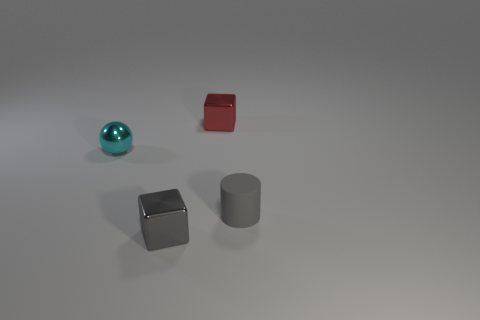There is a shiny thing in front of the small gray object that is on the right side of the small red object; what number of metallic balls are to the right of it?
Provide a short and direct response. 0. There is a metallic sphere; is its color the same as the tiny thing that is in front of the tiny cylinder?
Offer a terse response. No. What number of things are either objects that are behind the tiny cyan ball or tiny blocks that are behind the tiny rubber cylinder?
Give a very brief answer. 1. Are there more cylinders that are to the left of the red metal thing than metal cubes behind the small cyan object?
Make the answer very short. No. The block that is in front of the gray object that is behind the tiny object in front of the matte object is made of what material?
Make the answer very short. Metal. Does the tiny metallic thing that is in front of the small matte cylinder have the same shape as the tiny gray thing that is on the right side of the red shiny thing?
Give a very brief answer. No. Is there a yellow rubber thing that has the same size as the red metallic thing?
Offer a terse response. No. How many red things are small blocks or matte things?
Ensure brevity in your answer.  1. What number of objects are the same color as the tiny metal ball?
Your response must be concise. 0. Is there anything else that has the same shape as the small cyan thing?
Offer a very short reply. No. 